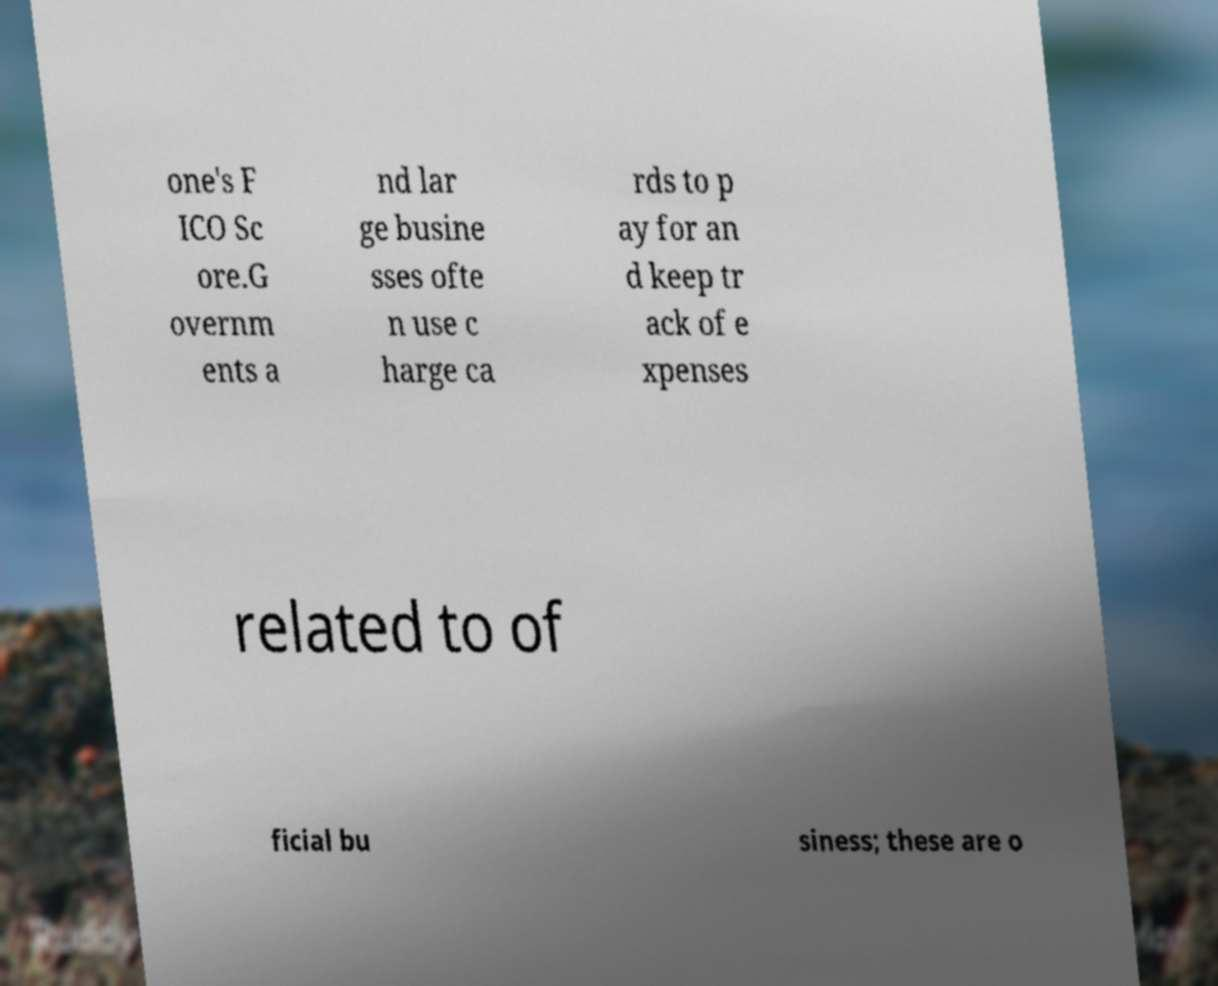Could you assist in decoding the text presented in this image and type it out clearly? one's F ICO Sc ore.G overnm ents a nd lar ge busine sses ofte n use c harge ca rds to p ay for an d keep tr ack of e xpenses related to of ficial bu siness; these are o 